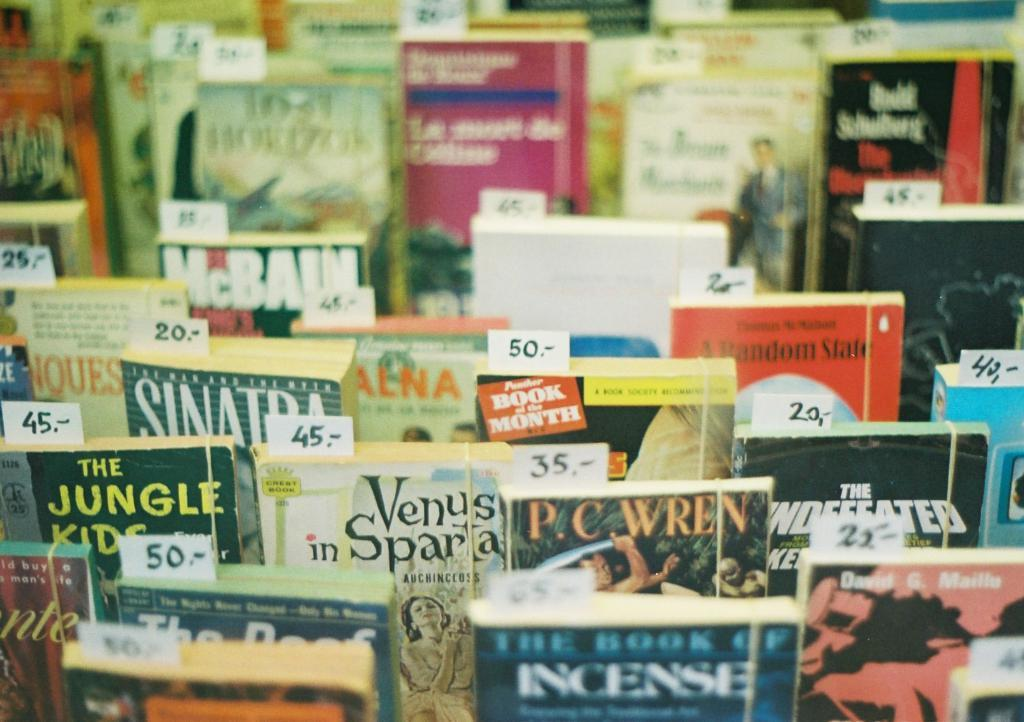<image>
Create a compact narrative representing the image presented. A series of books at a bookstore with prices on them 